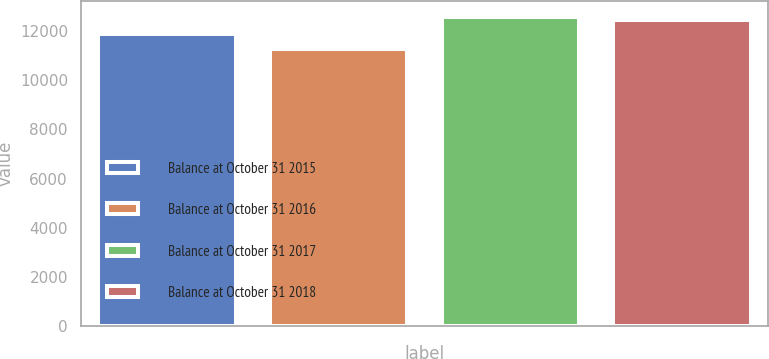Convert chart. <chart><loc_0><loc_0><loc_500><loc_500><bar_chart><fcel>Balance at October 31 2015<fcel>Balance at October 31 2016<fcel>Balance at October 31 2017<fcel>Balance at October 31 2018<nl><fcel>11883<fcel>11244<fcel>12583<fcel>12439<nl></chart> 